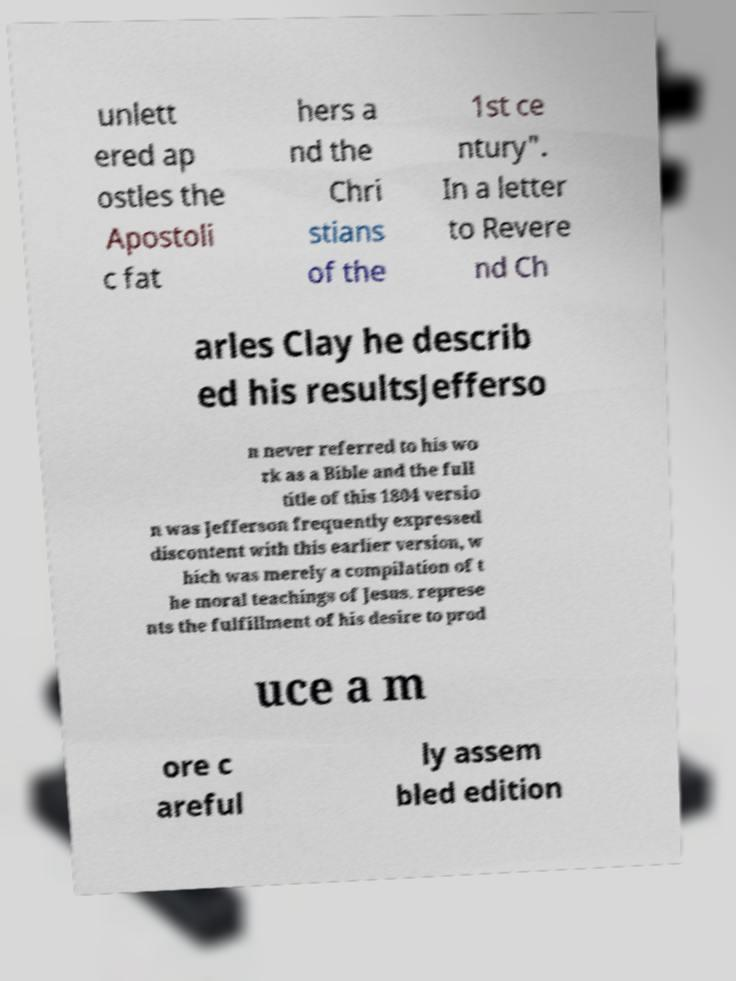For documentation purposes, I need the text within this image transcribed. Could you provide that? unlett ered ap ostles the Apostoli c fat hers a nd the Chri stians of the 1st ce ntury". In a letter to Revere nd Ch arles Clay he describ ed his resultsJefferso n never referred to his wo rk as a Bible and the full title of this 1804 versio n was Jefferson frequently expressed discontent with this earlier version, w hich was merely a compilation of t he moral teachings of Jesus. represe nts the fulfillment of his desire to prod uce a m ore c areful ly assem bled edition 